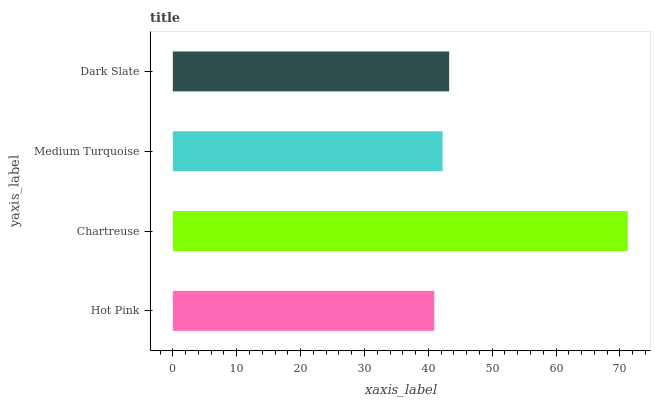Is Hot Pink the minimum?
Answer yes or no. Yes. Is Chartreuse the maximum?
Answer yes or no. Yes. Is Medium Turquoise the minimum?
Answer yes or no. No. Is Medium Turquoise the maximum?
Answer yes or no. No. Is Chartreuse greater than Medium Turquoise?
Answer yes or no. Yes. Is Medium Turquoise less than Chartreuse?
Answer yes or no. Yes. Is Medium Turquoise greater than Chartreuse?
Answer yes or no. No. Is Chartreuse less than Medium Turquoise?
Answer yes or no. No. Is Dark Slate the high median?
Answer yes or no. Yes. Is Medium Turquoise the low median?
Answer yes or no. Yes. Is Medium Turquoise the high median?
Answer yes or no. No. Is Dark Slate the low median?
Answer yes or no. No. 